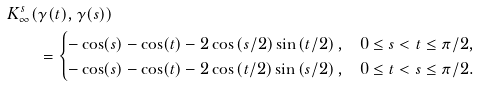Convert formula to latex. <formula><loc_0><loc_0><loc_500><loc_500>K _ { \infty } ^ { s } ( & \gamma ( t ) , \gamma ( s ) ) \\ & = \begin{cases} - \cos ( s ) - \cos ( t ) - 2 \cos \left ( s / 2 \right ) \sin \left ( t / 2 \right ) , & 0 \leq s < t \leq \pi / 2 , \\ - \cos ( s ) - \cos ( t ) - 2 \cos \left ( t / 2 \right ) \sin \left ( s / 2 \right ) , & 0 \leq t < s \leq \pi / 2 . \end{cases}</formula> 